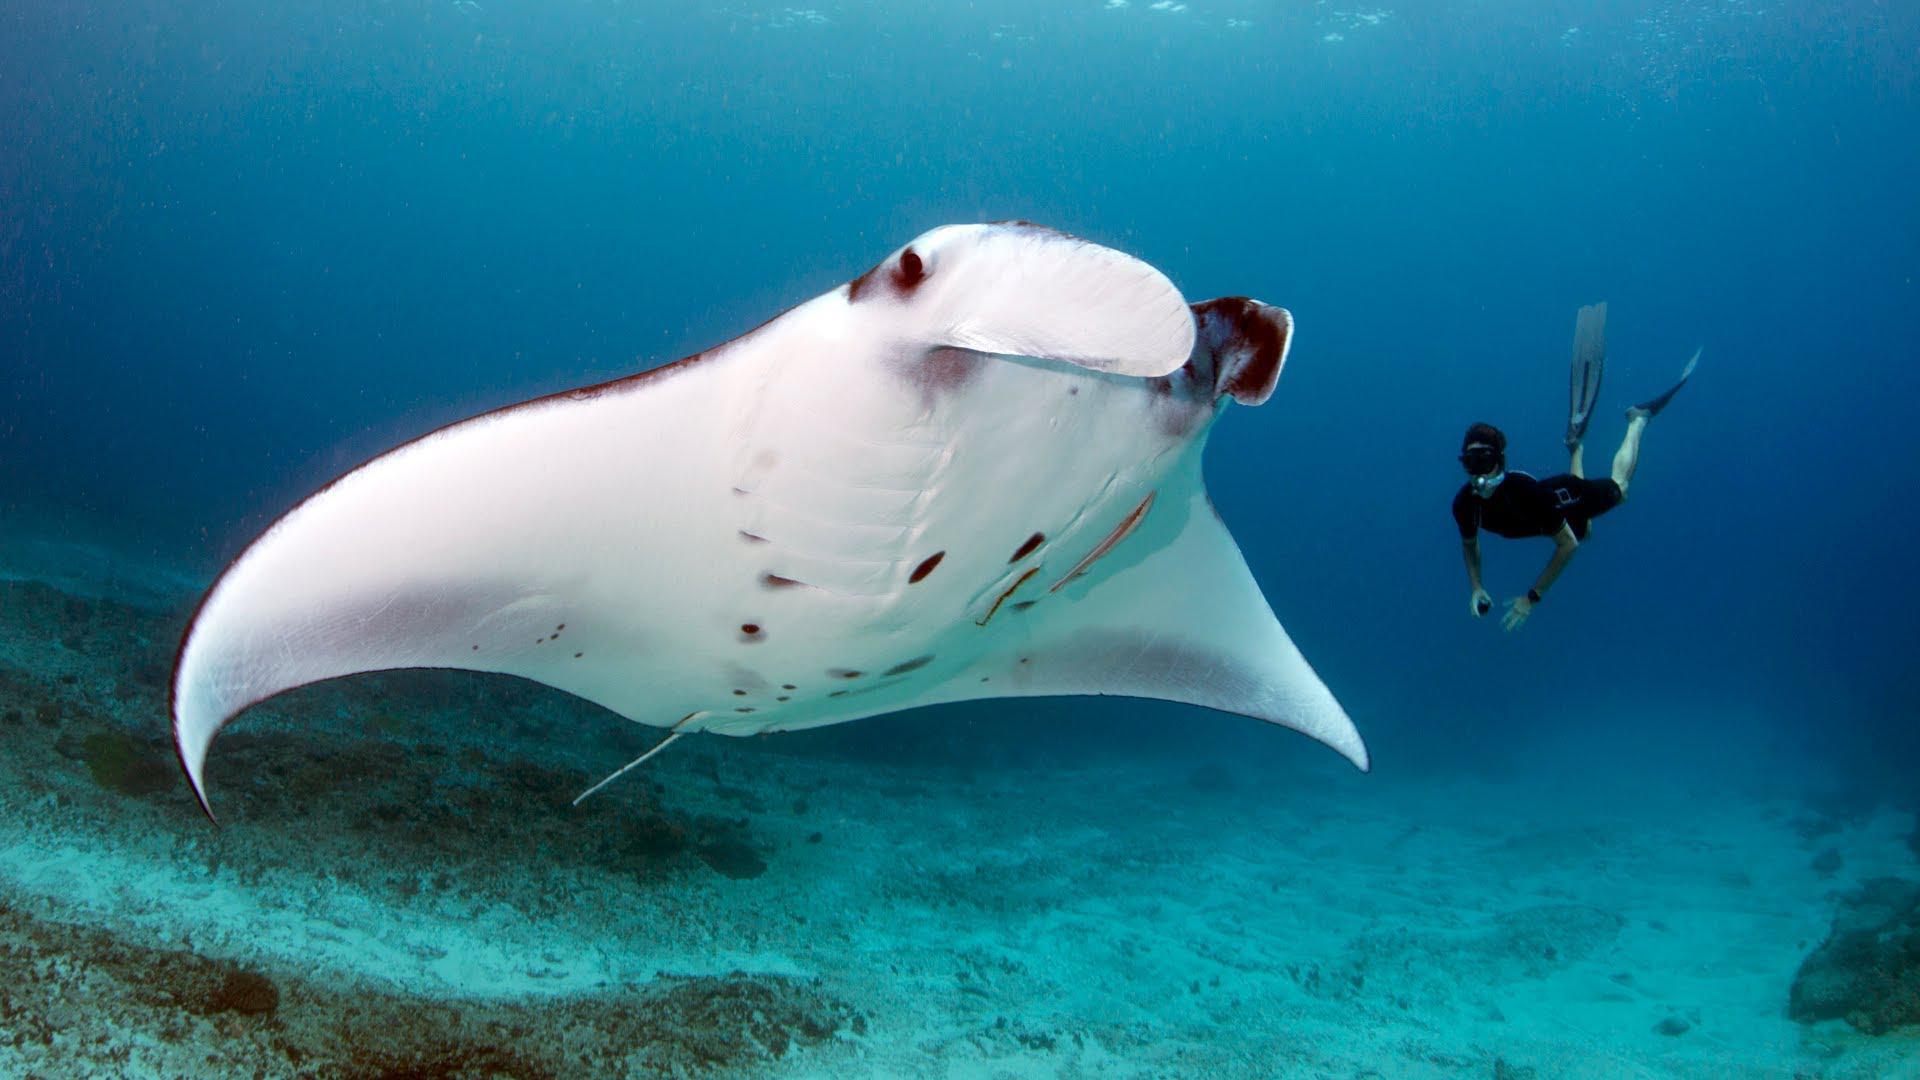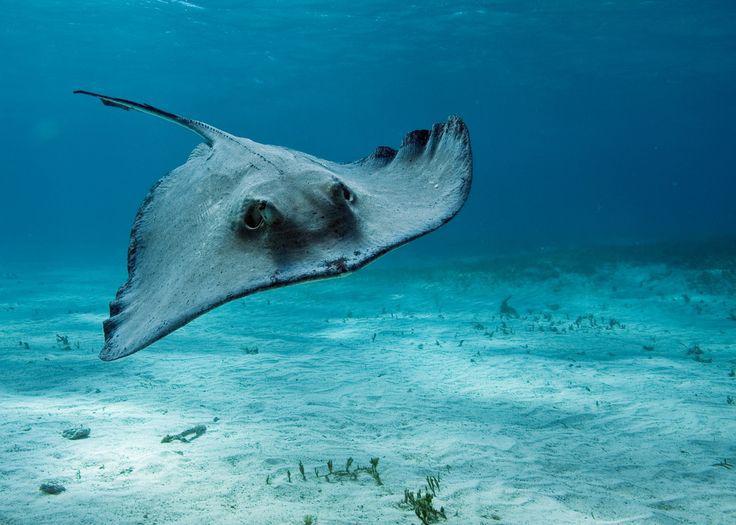The first image is the image on the left, the second image is the image on the right. Considering the images on both sides, is "There are no more than two stingrays." valid? Answer yes or no. Yes. 